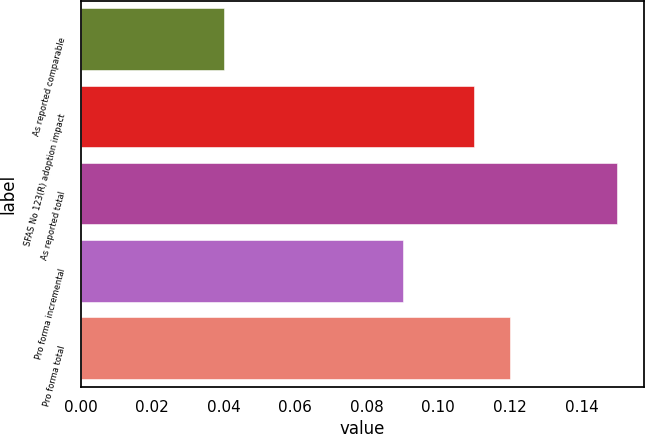Convert chart to OTSL. <chart><loc_0><loc_0><loc_500><loc_500><bar_chart><fcel>As reported comparable<fcel>SFAS No 123(R) adoption impact<fcel>As reported total<fcel>Pro forma incremental<fcel>Pro forma total<nl><fcel>0.04<fcel>0.11<fcel>0.15<fcel>0.09<fcel>0.12<nl></chart> 